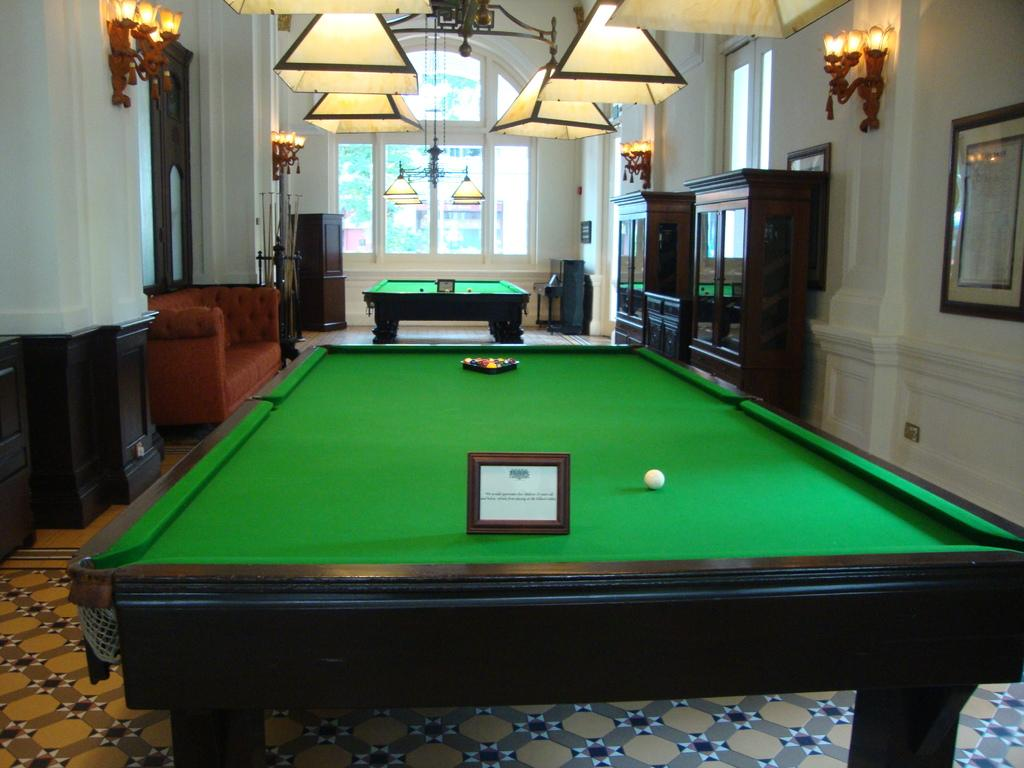How many snooker tables are in the image? There are two snooker tables in the image. What type of furniture is present in the image? There is a sofa in the image. Can you describe the lighting in the image? There are multiple lights visible in the image. What type of government is depicted in the image? There is no depiction of a government in the image; it features snooker tables, a sofa, and lights. How many eggs are visible in the image? There are no eggs present in the image. 